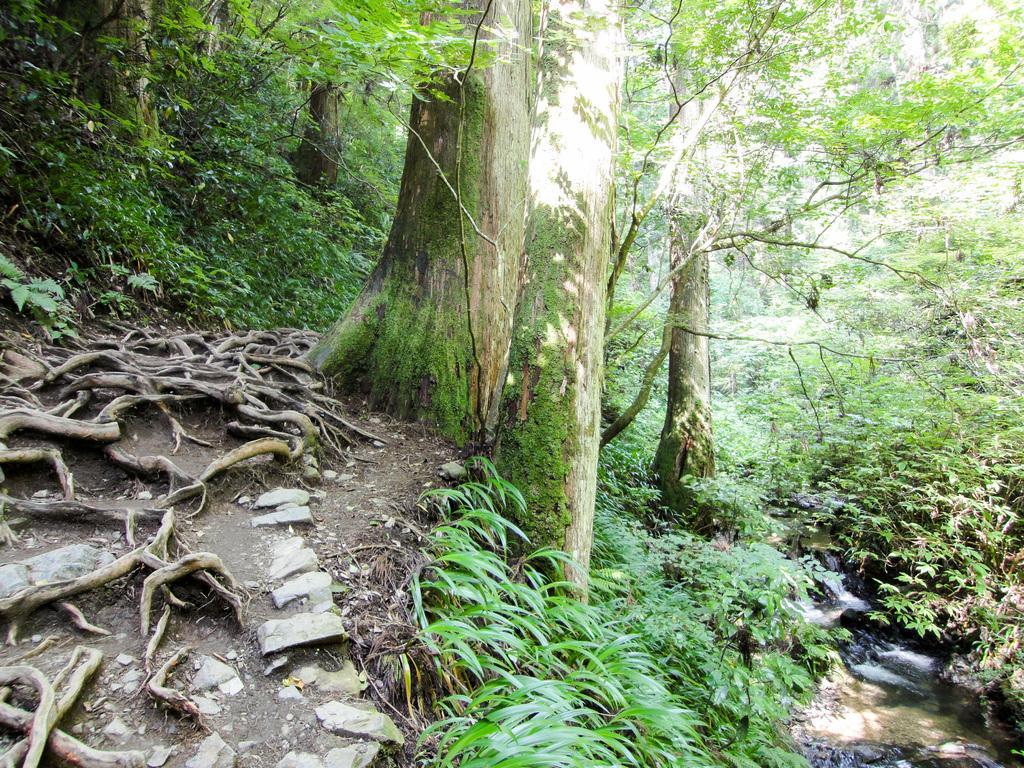Describe this image in one or two sentences. In this image we can see trees and plants on the ground and we can see roots of trees and stones on the left side. On the right side we can see water is flowing on the ground. 